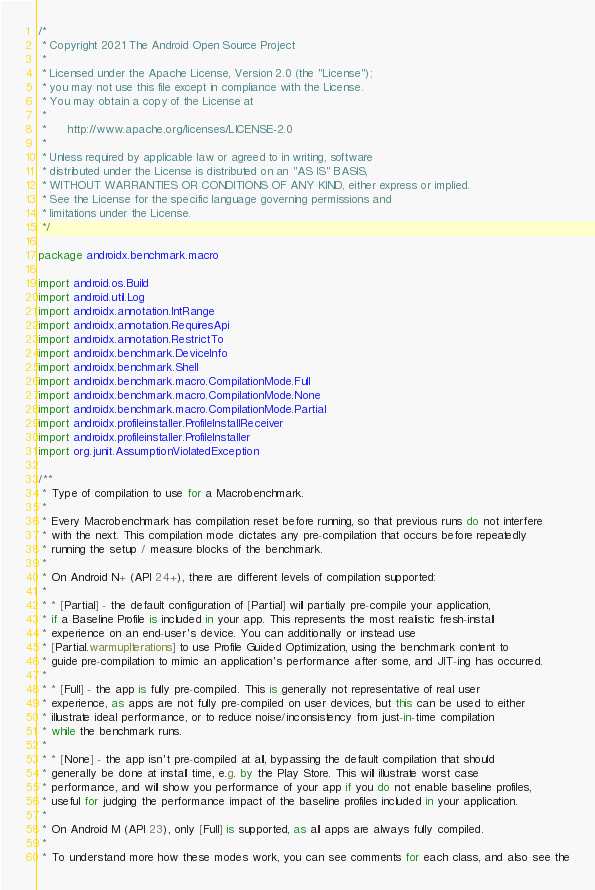<code> <loc_0><loc_0><loc_500><loc_500><_Kotlin_>/*
 * Copyright 2021 The Android Open Source Project
 *
 * Licensed under the Apache License, Version 2.0 (the "License");
 * you may not use this file except in compliance with the License.
 * You may obtain a copy of the License at
 *
 *      http://www.apache.org/licenses/LICENSE-2.0
 *
 * Unless required by applicable law or agreed to in writing, software
 * distributed under the License is distributed on an "AS IS" BASIS,
 * WITHOUT WARRANTIES OR CONDITIONS OF ANY KIND, either express or implied.
 * See the License for the specific language governing permissions and
 * limitations under the License.
 */

package androidx.benchmark.macro

import android.os.Build
import android.util.Log
import androidx.annotation.IntRange
import androidx.annotation.RequiresApi
import androidx.annotation.RestrictTo
import androidx.benchmark.DeviceInfo
import androidx.benchmark.Shell
import androidx.benchmark.macro.CompilationMode.Full
import androidx.benchmark.macro.CompilationMode.None
import androidx.benchmark.macro.CompilationMode.Partial
import androidx.profileinstaller.ProfileInstallReceiver
import androidx.profileinstaller.ProfileInstaller
import org.junit.AssumptionViolatedException

/**
 * Type of compilation to use for a Macrobenchmark.
 *
 * Every Macrobenchmark has compilation reset before running, so that previous runs do not interfere
 * with the next. This compilation mode dictates any pre-compilation that occurs before repeatedly
 * running the setup / measure blocks of the benchmark.
 *
 * On Android N+ (API 24+), there are different levels of compilation supported:
 *
 * * [Partial] - the default configuration of [Partial] will partially pre-compile your application,
 * if a Baseline Profile is included in your app. This represents the most realistic fresh-install
 * experience on an end-user's device. You can additionally or instead use
 * [Partial.warmupIterations] to use Profile Guided Optimization, using the benchmark content to
 * guide pre-compilation to mimic an application's performance after some, and JIT-ing has occurred.
 *
 * * [Full] - the app is fully pre-compiled. This is generally not representative of real user
 * experience, as apps are not fully pre-compiled on user devices, but this can be used to either
 * illustrate ideal performance, or to reduce noise/inconsistency from just-in-time compilation
 * while the benchmark runs.
 *
 * * [None] - the app isn't pre-compiled at all, bypassing the default compilation that should
 * generally be done at install time, e.g. by the Play Store. This will illustrate worst case
 * performance, and will show you performance of your app if you do not enable baseline profiles,
 * useful for judging the performance impact of the baseline profiles included in your application.
 *
 * On Android M (API 23), only [Full] is supported, as all apps are always fully compiled.
 *
 * To understand more how these modes work, you can see comments for each class, and also see the</code> 